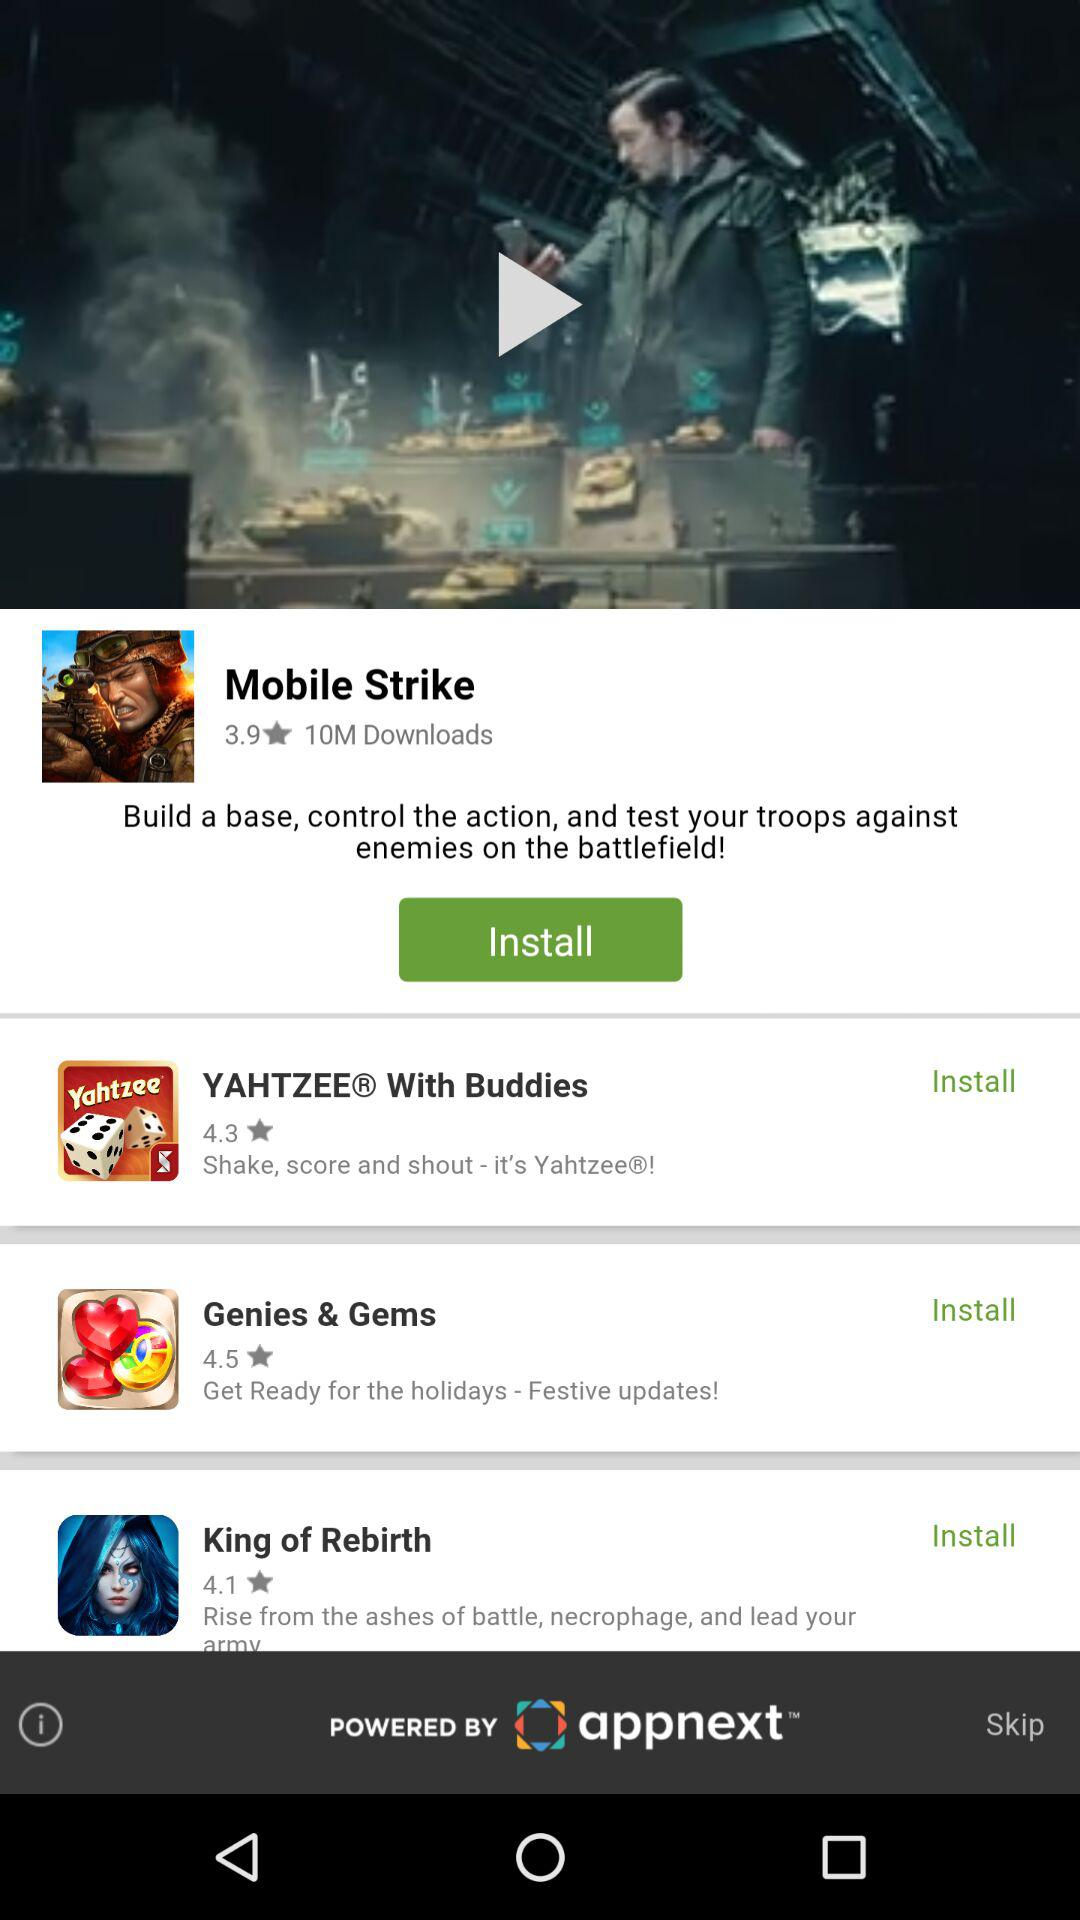Is Genies & Gems installed or uninstalled?
When the provided information is insufficient, respond with <no answer>. <no answer> 